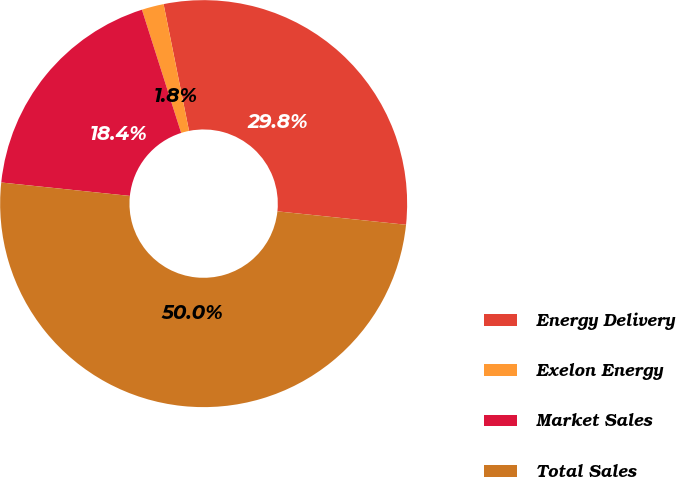<chart> <loc_0><loc_0><loc_500><loc_500><pie_chart><fcel>Energy Delivery<fcel>Exelon Energy<fcel>Market Sales<fcel>Total Sales<nl><fcel>29.81%<fcel>1.75%<fcel>18.44%<fcel>50.0%<nl></chart> 